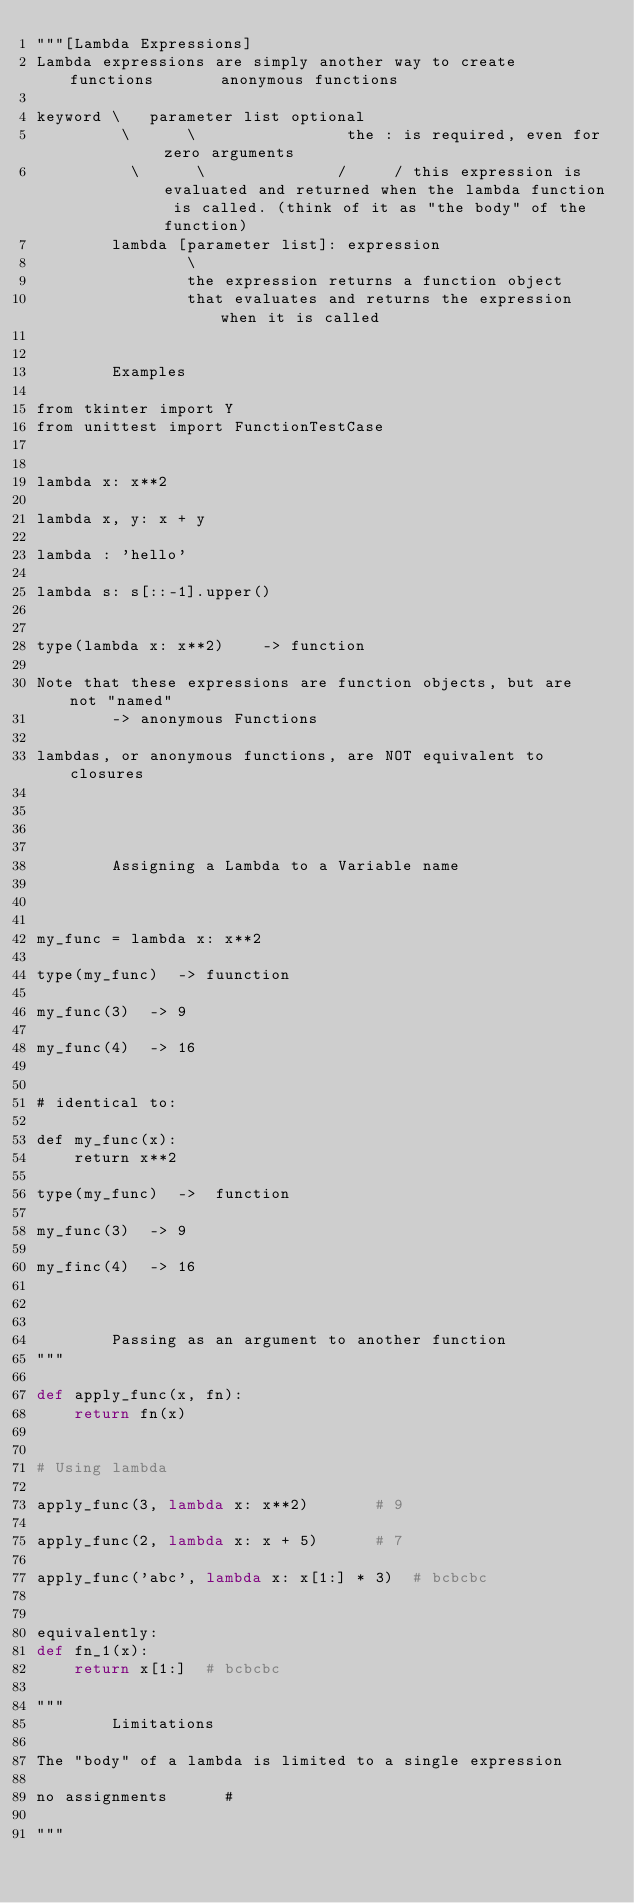Convert code to text. <code><loc_0><loc_0><loc_500><loc_500><_Python_>"""[Lambda Expressions]
Lambda expressions are simply another way to create functions       anonymous functions

keyword \   parameter list optional
         \      \                the : is required, even for zero arguments
          \      \              /     / this expression is evaluated and returned when the lambda function is called. (think of it as "the body" of the function)
        lambda [parameter list]: expression
                \
                the expression returns a function object
                that evaluates and returns the expression when it is called


        Examples

from tkinter import Y
from unittest import FunctionTestCase


lambda x: x**2

lambda x, y: x + y

lambda : 'hello'

lambda s: s[::-1].upper()


type(lambda x: x**2)    -> function

Note that these expressions are function objects, but are not "named"
        -> anonymous Functions

lambdas, or anonymous functions, are NOT equivalent to closures




        Assigning a Lambda to a Variable name



my_func = lambda x: x**2

type(my_func)  -> fuunction

my_func(3)  -> 9

my_func(4)  -> 16


# identical to:

def my_func(x):
	return x**2

type(my_func)  ->  function

my_func(3)  -> 9

my_finc(4)  -> 16



        Passing as an argument to another function
"""

def apply_func(x, fn):
    return fn(x)


# Using lambda

apply_func(3, lambda x: x**2)		# 9

apply_func(2, lambda x: x + 5)		# 7

apply_func('abc', lambda x: x[1:] * 3)	# bcbcbc


equivalently:
def fn_1(x):
    return x[1:]  # bcbcbc

"""
		Limitations

The "body" of a lambda is limited to a single expression

no assignments		# 

"""

</code> 